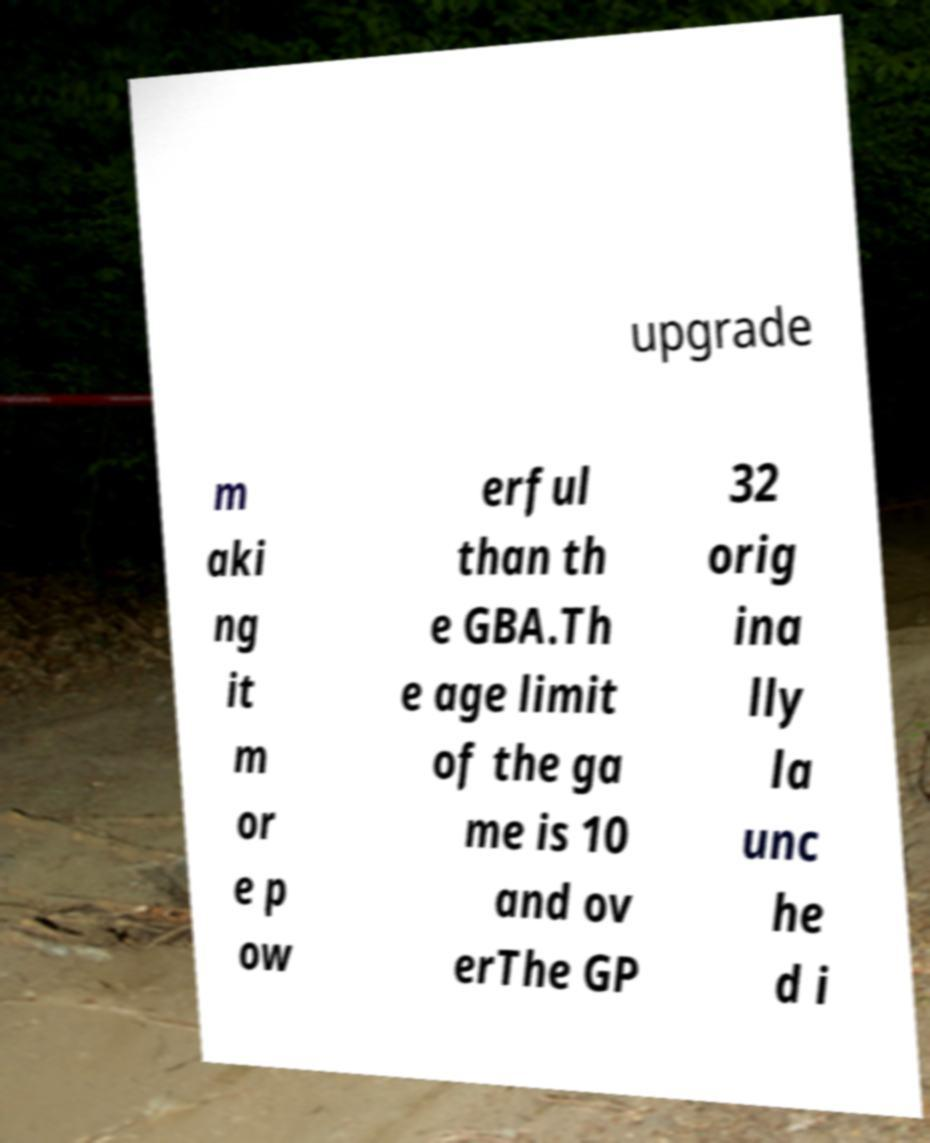Please read and relay the text visible in this image. What does it say? upgrade m aki ng it m or e p ow erful than th e GBA.Th e age limit of the ga me is 10 and ov erThe GP 32 orig ina lly la unc he d i 